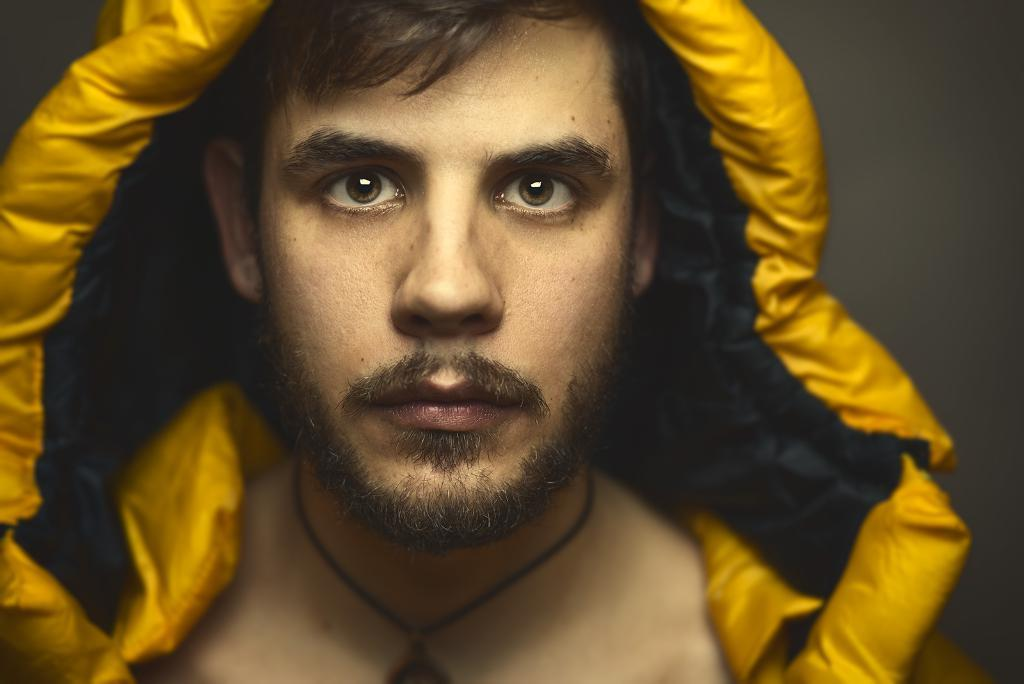Who is present in the image? There is a man in the image. How is the man depicted in the image? The man is truncated. What can be observed about the background of the image? The background of the image is dark. What type of attraction can be seen in the background of the image? There is no attraction visible in the background of the image; it is dark. Can you point out the location of the map in the image? There is no map present in the image. 